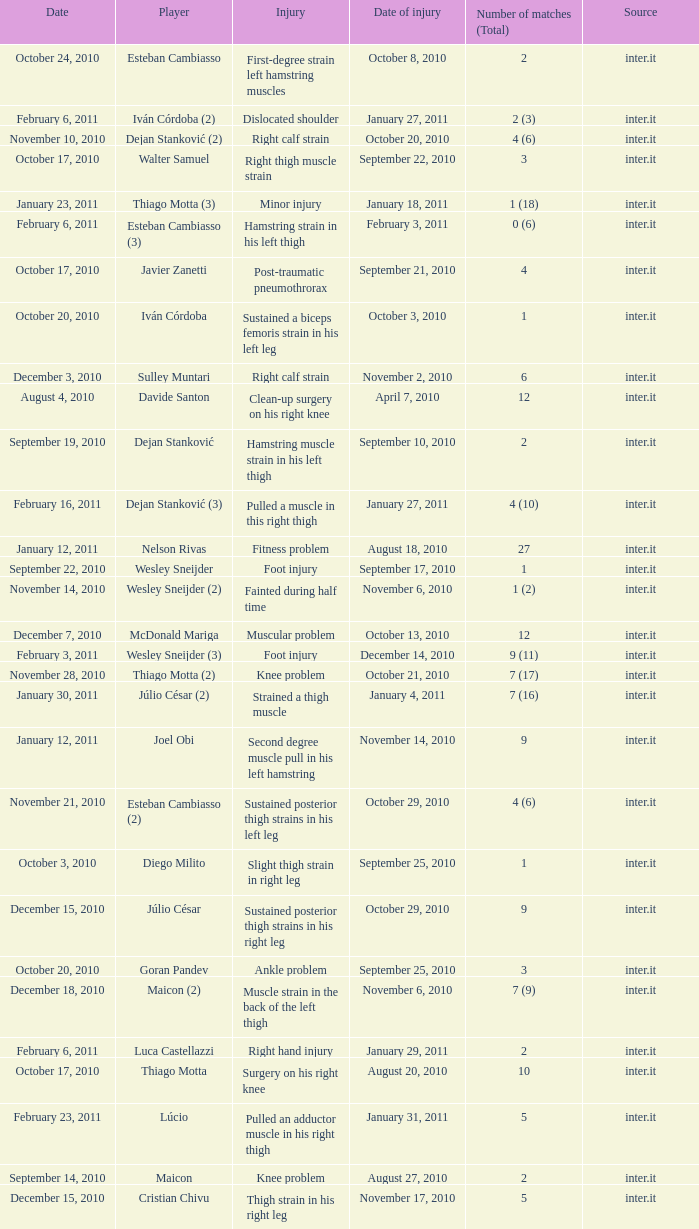What is the date of injury when the injury is foot injury and the number of matches (total) is 1? September 17, 2010. 